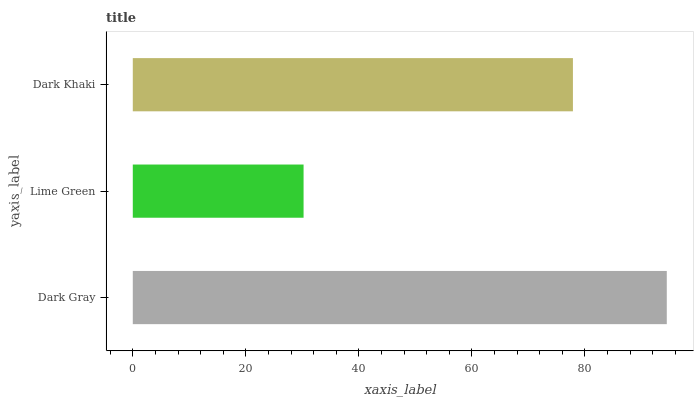Is Lime Green the minimum?
Answer yes or no. Yes. Is Dark Gray the maximum?
Answer yes or no. Yes. Is Dark Khaki the minimum?
Answer yes or no. No. Is Dark Khaki the maximum?
Answer yes or no. No. Is Dark Khaki greater than Lime Green?
Answer yes or no. Yes. Is Lime Green less than Dark Khaki?
Answer yes or no. Yes. Is Lime Green greater than Dark Khaki?
Answer yes or no. No. Is Dark Khaki less than Lime Green?
Answer yes or no. No. Is Dark Khaki the high median?
Answer yes or no. Yes. Is Dark Khaki the low median?
Answer yes or no. Yes. Is Lime Green the high median?
Answer yes or no. No. Is Dark Gray the low median?
Answer yes or no. No. 